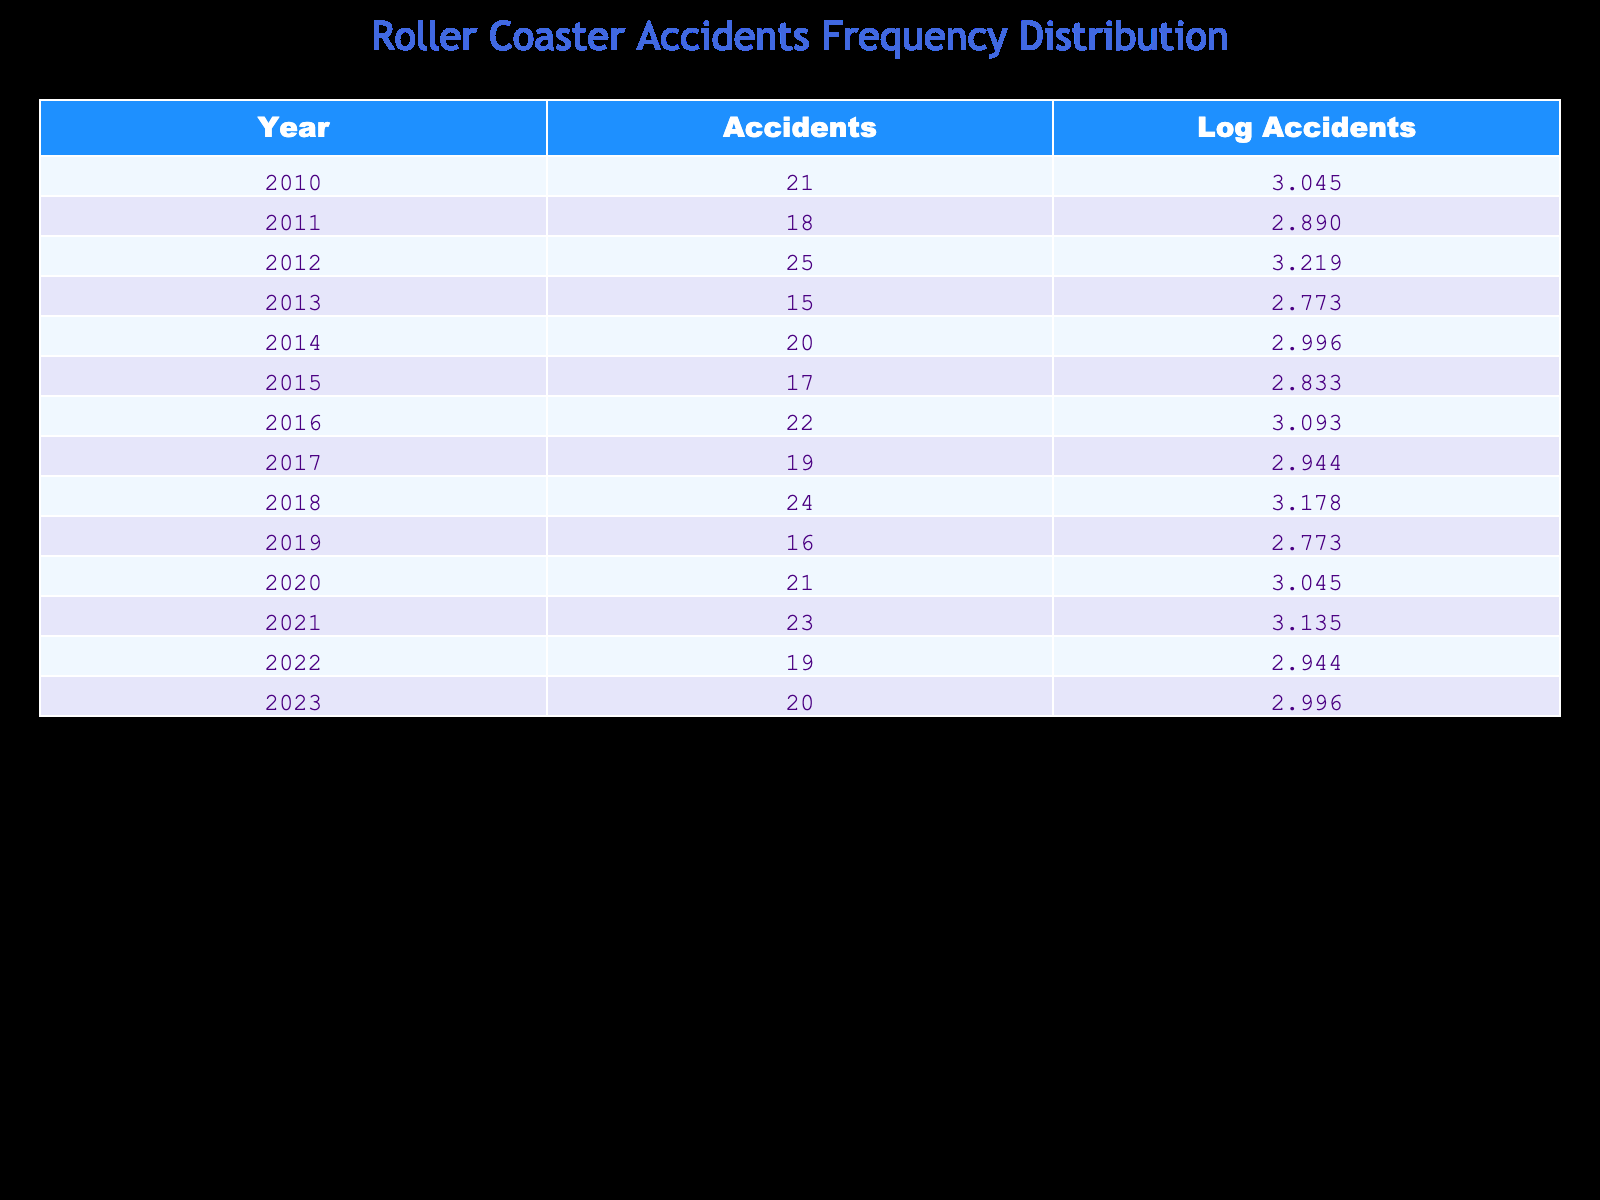What year had the highest number of roller coaster accidents? Looking at the "Accidents" column, the year with the highest value is 2012, which had 25 accidents.
Answer: 2012 What was the number of accidents in 2016? Referring to the "Accidents" column for the year 2016, it shows 22 accidents.
Answer: 22 How many total roller coaster accidents occurred from 2010 to 2023? By summing the accidents for each year from the "Accidents" column: 21 + 18 + 25 + 15 + 20 + 17 + 22 + 19 + 24 + 16 + 21 + 23 + 19 + 20 =  252.
Answer: 252 What is the average number of accidents per year from 2010 to 2023? There are 14 years in the data (from 2010 to 2023), and the total number of accidents is 252. Thus, the average is 252/14 = 18. If checking the result: 252 divided by 14 equals 18.
Answer: 18 Was there a year with no roller coaster accidents? Upon examining the "Accidents" column for the years provided, every year has a recorded number of accidents, so no year had zero accidents.
Answer: No Did the number of roller coaster accidents generally increase over the years? Analyzing the "Accidents" values across the years, while some years had more accidents than others, the general trend fluctuates with no consistent upward or downward slope. Specifically, it increased in some years (2012, 2016, and 2018) but decreased in others (2011, 2013, and 2019).
Answer: No (general trend) What is the logarithmic value of accidents for the year 2021? The "Log Accidents" column shows that the value for 2021 is 3.135494.
Answer: 3.135494 Which years had fewer than 20 accidents? Referring to the "Accidents" column, the years with fewer than 20 accidents are 2011 (18), 2013 (15), 2015 (17), 2019 (16), and 2022 (19).
Answer: 2011, 2013, 2015, 2019, 2022 What was the difference in the number of accidents between the highest (2012) and the lowest (2013) years? In 2012, the number of accidents was 25, and in 2013, it was 15. The difference is 25 - 15 = 10. This implies that there were significantly more accidents in 2012 than in 2013.
Answer: 10 